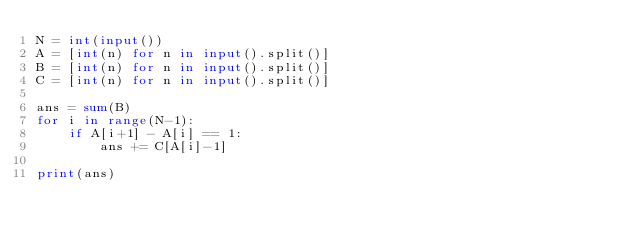Convert code to text. <code><loc_0><loc_0><loc_500><loc_500><_Python_>N = int(input())
A = [int(n) for n in input().split()]
B = [int(n) for n in input().split()]
C = [int(n) for n in input().split()]

ans = sum(B)
for i in range(N-1):
    if A[i+1] - A[i] == 1:
        ans += C[A[i]-1]

print(ans)</code> 